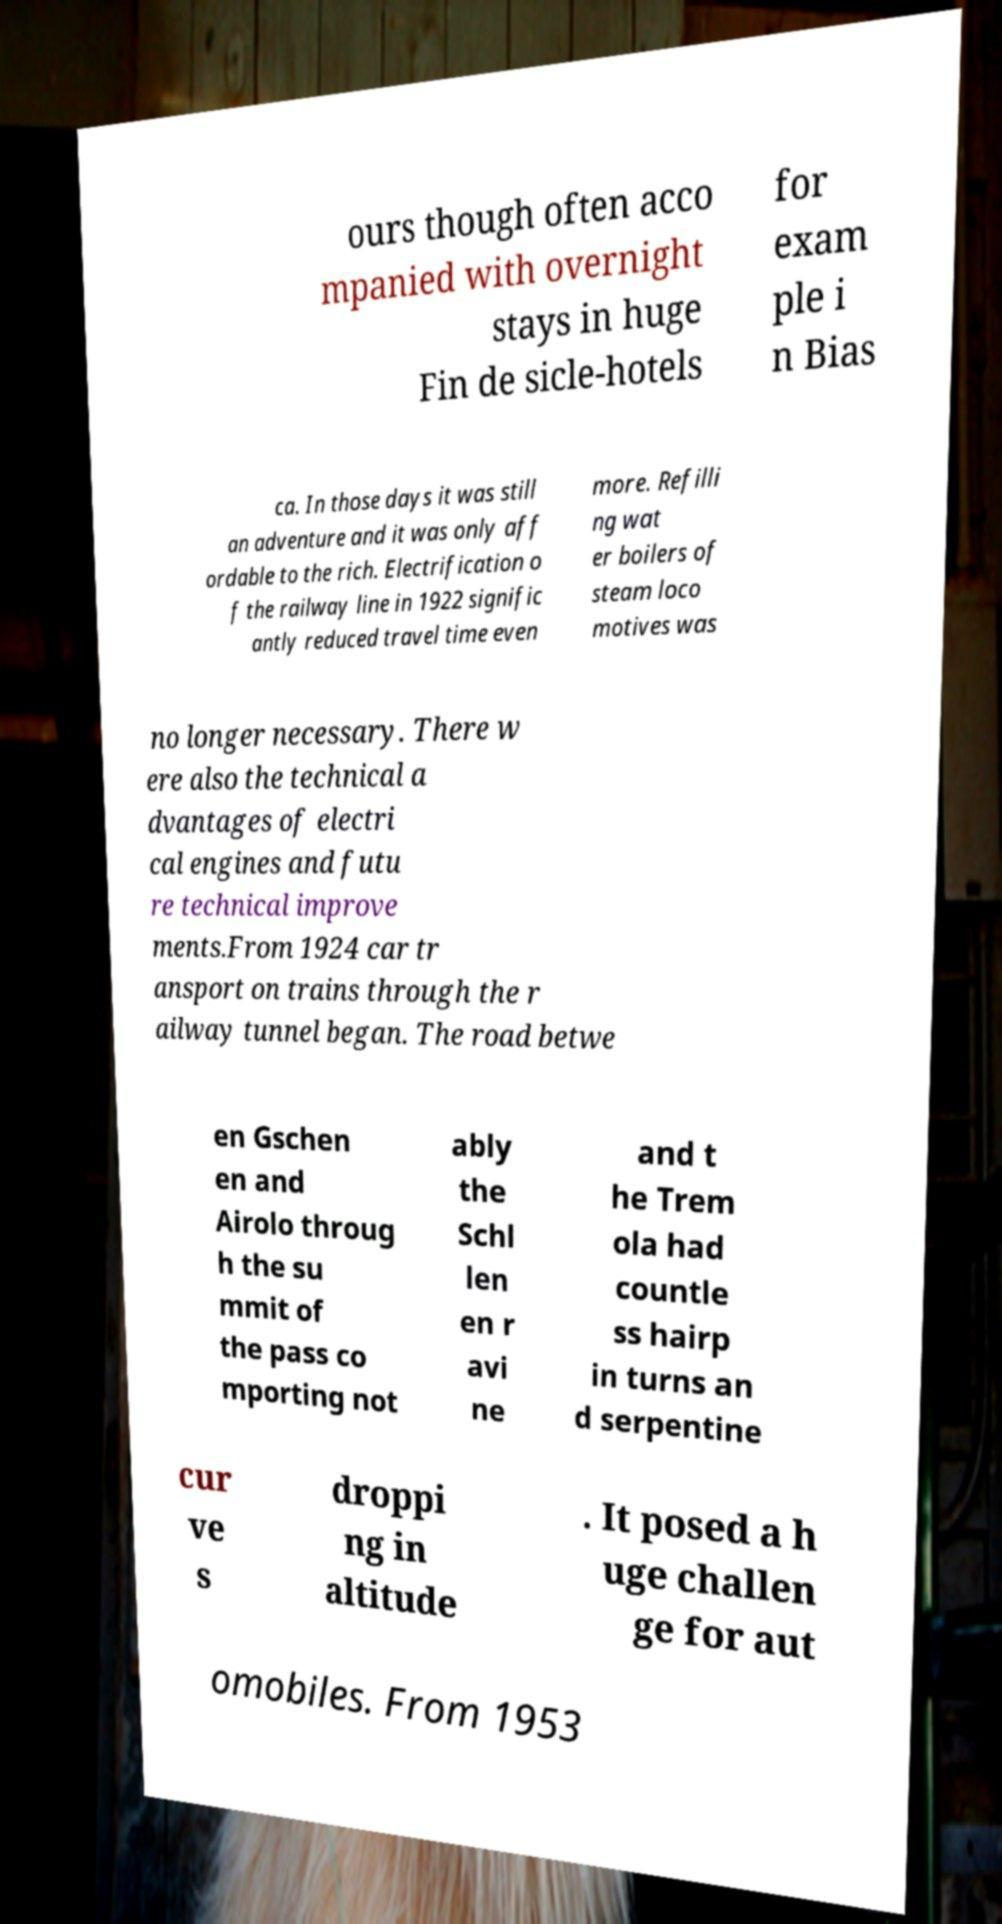For documentation purposes, I need the text within this image transcribed. Could you provide that? ours though often acco mpanied with overnight stays in huge Fin de sicle-hotels for exam ple i n Bias ca. In those days it was still an adventure and it was only aff ordable to the rich. Electrification o f the railway line in 1922 signific antly reduced travel time even more. Refilli ng wat er boilers of steam loco motives was no longer necessary. There w ere also the technical a dvantages of electri cal engines and futu re technical improve ments.From 1924 car tr ansport on trains through the r ailway tunnel began. The road betwe en Gschen en and Airolo throug h the su mmit of the pass co mporting not ably the Schl len en r avi ne and t he Trem ola had countle ss hairp in turns an d serpentine cur ve s droppi ng in altitude . It posed a h uge challen ge for aut omobiles. From 1953 